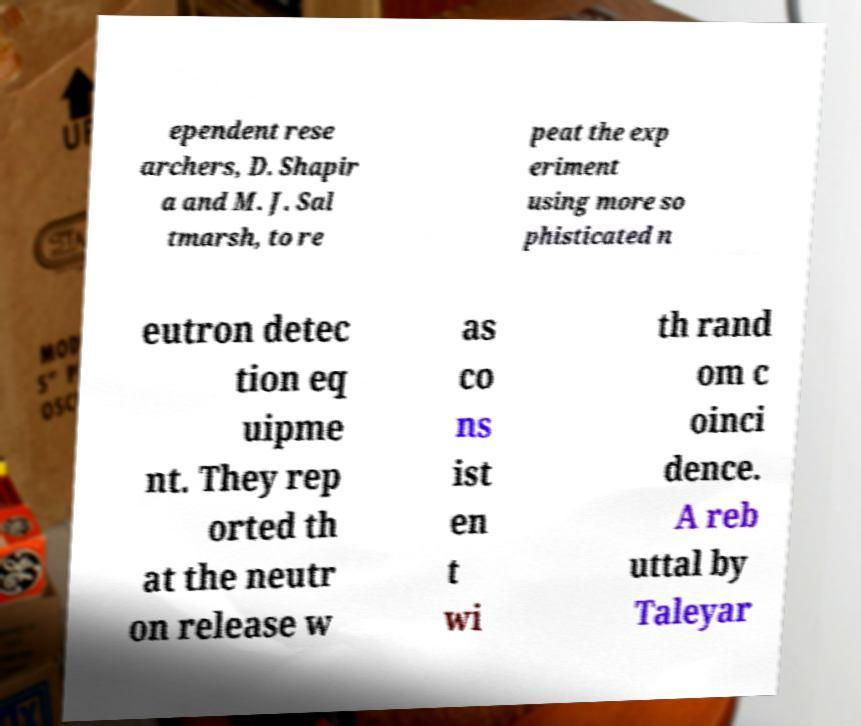Please read and relay the text visible in this image. What does it say? ependent rese archers, D. Shapir a and M. J. Sal tmarsh, to re peat the exp eriment using more so phisticated n eutron detec tion eq uipme nt. They rep orted th at the neutr on release w as co ns ist en t wi th rand om c oinci dence. A reb uttal by Taleyar 